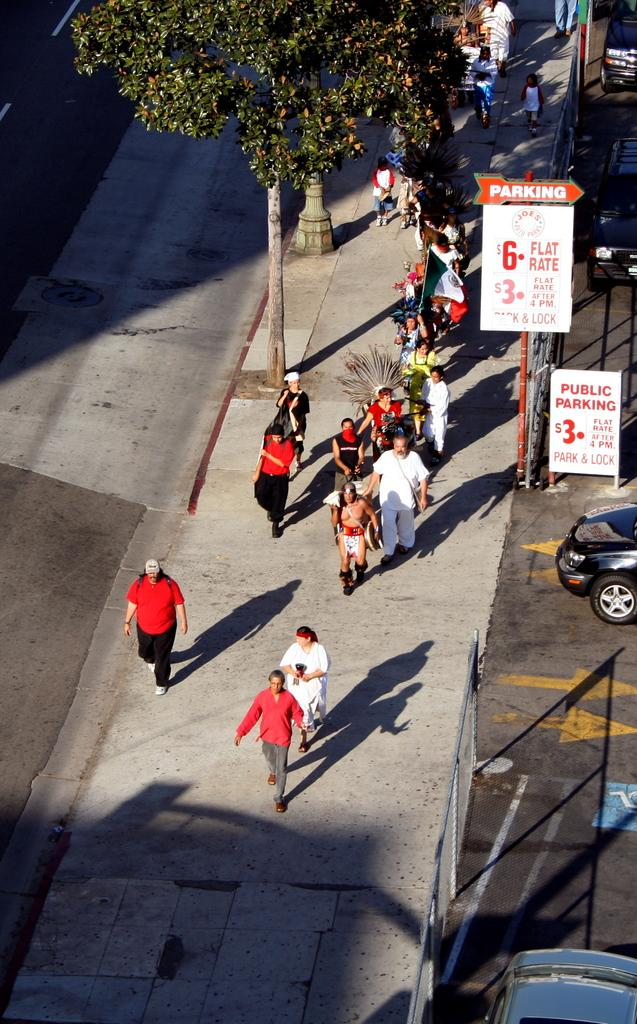How many people are in the image? There is a group of people in the image. What are the people doing in the image? The people are walking on the ground. What natural element can be seen in the image? There is a tree in the image. What type of man-made objects are visible in the image? There are cars on the road in the image. What type of alarm can be heard going off in the image? There is no alarm present in the image, and therefore no sound can be heard. 